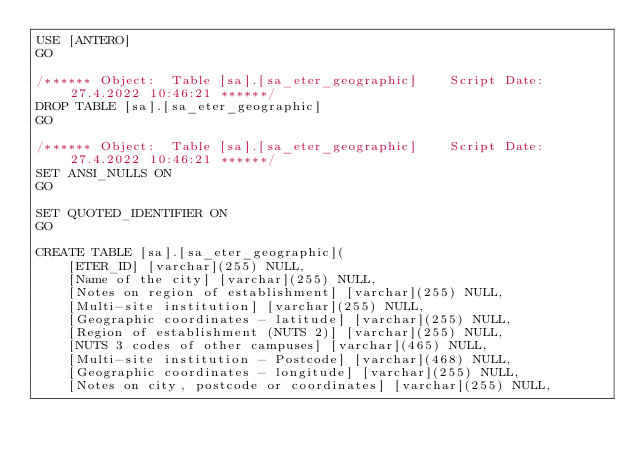<code> <loc_0><loc_0><loc_500><loc_500><_SQL_>USE [ANTERO]
GO

/****** Object:  Table [sa].[sa_eter_geographic]    Script Date: 27.4.2022 10:46:21 ******/
DROP TABLE [sa].[sa_eter_geographic]
GO

/****** Object:  Table [sa].[sa_eter_geographic]    Script Date: 27.4.2022 10:46:21 ******/
SET ANSI_NULLS ON
GO

SET QUOTED_IDENTIFIER ON
GO

CREATE TABLE [sa].[sa_eter_geographic](
	[ETER_ID] [varchar](255) NULL,
	[Name of the city] [varchar](255) NULL,
	[Notes on region of establishment] [varchar](255) NULL,
	[Multi-site institution] [varchar](255) NULL,
	[Geographic coordinates - latitude] [varchar](255) NULL,
	[Region of establishment (NUTS 2)] [varchar](255) NULL,
	[NUTS 3 codes of other campuses] [varchar](465) NULL,
	[Multi-site institution - Postcode] [varchar](468) NULL,
	[Geographic coordinates - longitude] [varchar](255) NULL,
	[Notes on city, postcode or coordinates] [varchar](255) NULL,</code> 